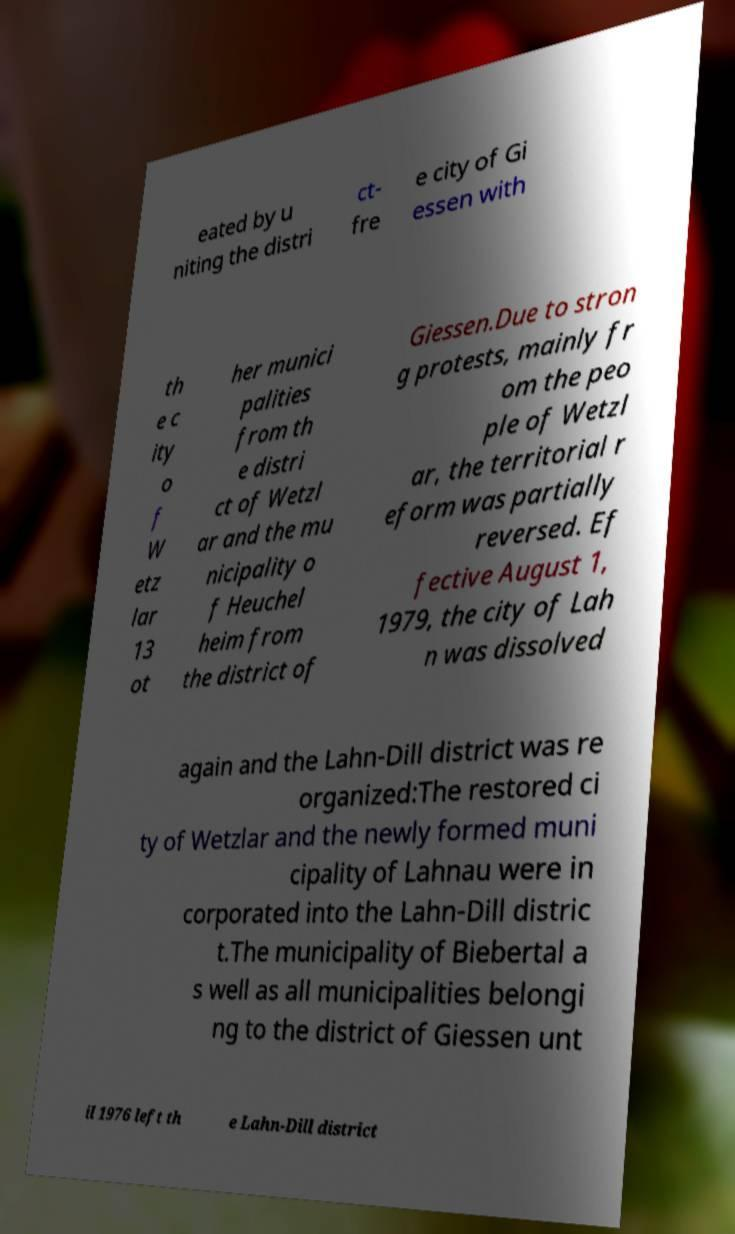Could you extract and type out the text from this image? eated by u niting the distri ct- fre e city of Gi essen with th e c ity o f W etz lar 13 ot her munici palities from th e distri ct of Wetzl ar and the mu nicipality o f Heuchel heim from the district of Giessen.Due to stron g protests, mainly fr om the peo ple of Wetzl ar, the territorial r eform was partially reversed. Ef fective August 1, 1979, the city of Lah n was dissolved again and the Lahn-Dill district was re organized:The restored ci ty of Wetzlar and the newly formed muni cipality of Lahnau were in corporated into the Lahn-Dill distric t.The municipality of Biebertal a s well as all municipalities belongi ng to the district of Giessen unt il 1976 left th e Lahn-Dill district 